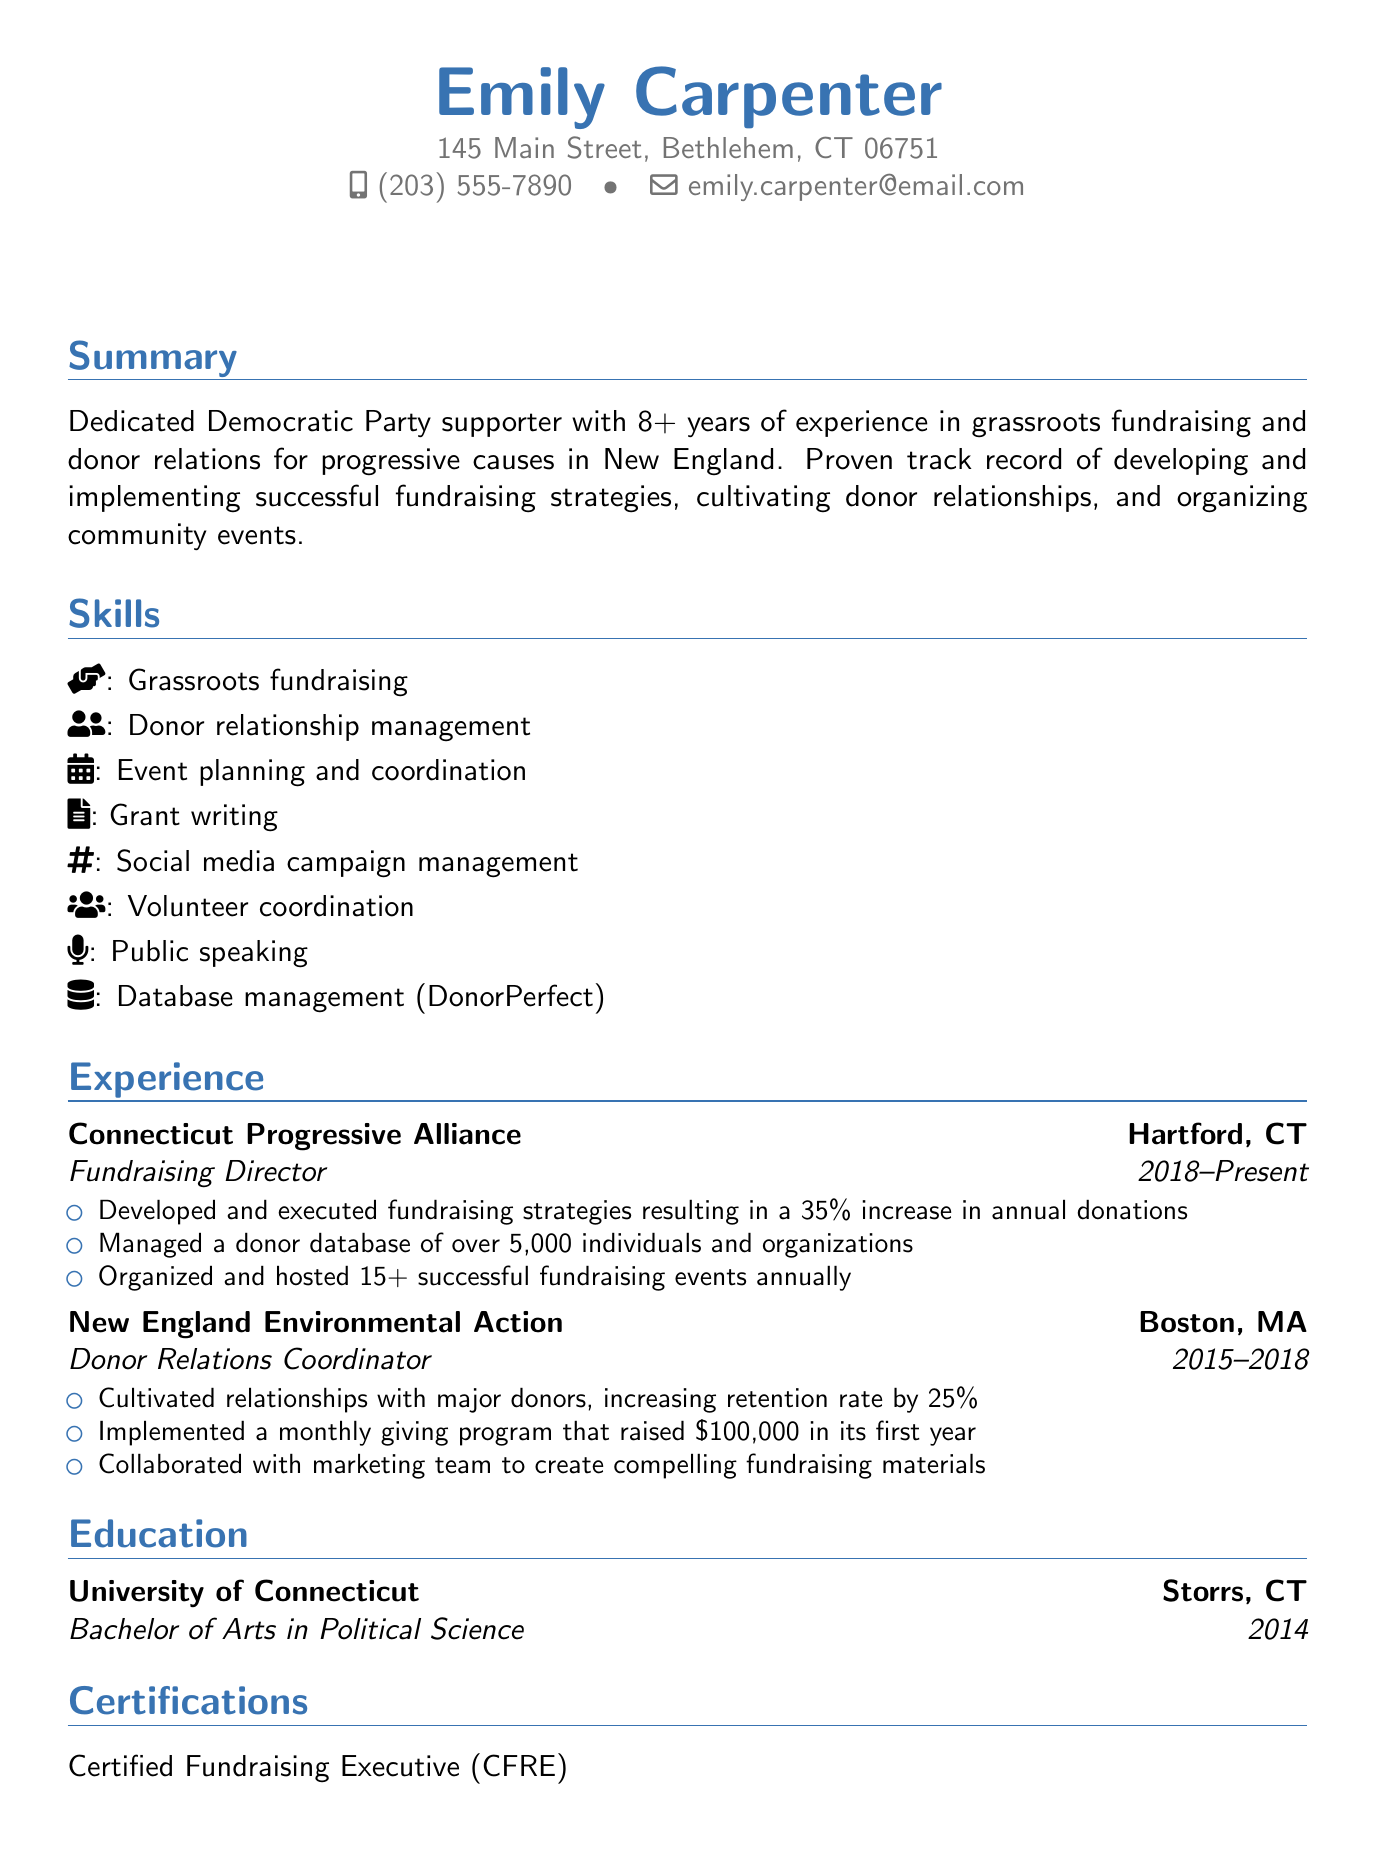What is Emily Carpenter's email address? The email address listed in the document is provided under personal information.
Answer: emily.carpenter@email.com How many years of experience does Emily have in grassroots fundraising? The summary section states Emily has 8+ years of experience.
Answer: 8+ What was Emily's role at the Connecticut Progressive Alliance? The title is specified under the experience section for that organization.
Answer: Fundraising Director Which university did Emily attend? This information can be found in the education section of the document.
Answer: University of Connecticut How much money did Emily's monthly giving program raise in its first year? The document specifies the amount raised in the responsibilities of the Donor Relations Coordinator position.
Answer: $100,000 What is one of the skills Emily has related to event management? The skills section lists specific abilities; one relates to events.
Answer: Event planning and coordination What certification has Emily achieved related to fundraising? Certifications provided in the document specifically mention fundraising-related qualifications.
Answer: Certified Fundraising Executive (CFRE) In which town does Emily volunteer as a Campaign Volunteer Coordinator? The volunteer work section gives the location of her volunteer efforts.
Answer: Bethlehem 